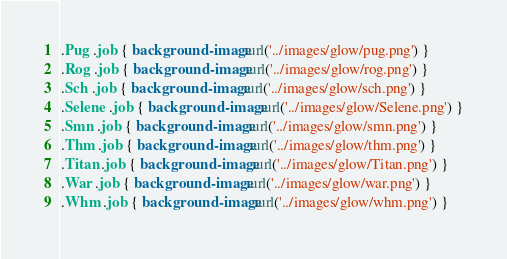<code> <loc_0><loc_0><loc_500><loc_500><_CSS_>.Pug .job { background-image:url('../images/glow/pug.png') }
.Rog .job { background-image:url('../images/glow/rog.png') }
.Sch .job { background-image:url('../images/glow/sch.png') }
.Selene .job { background-image:url('../images/glow/Selene.png') }
.Smn .job { background-image:url('../images/glow/smn.png') }
.Thm .job { background-image:url('../images/glow/thm.png') }
.Titan .job { background-image:url('../images/glow/Titan.png') }
.War .job { background-image:url('../images/glow/war.png') }
.Whm .job { background-image:url('../images/glow/whm.png') }</code> 